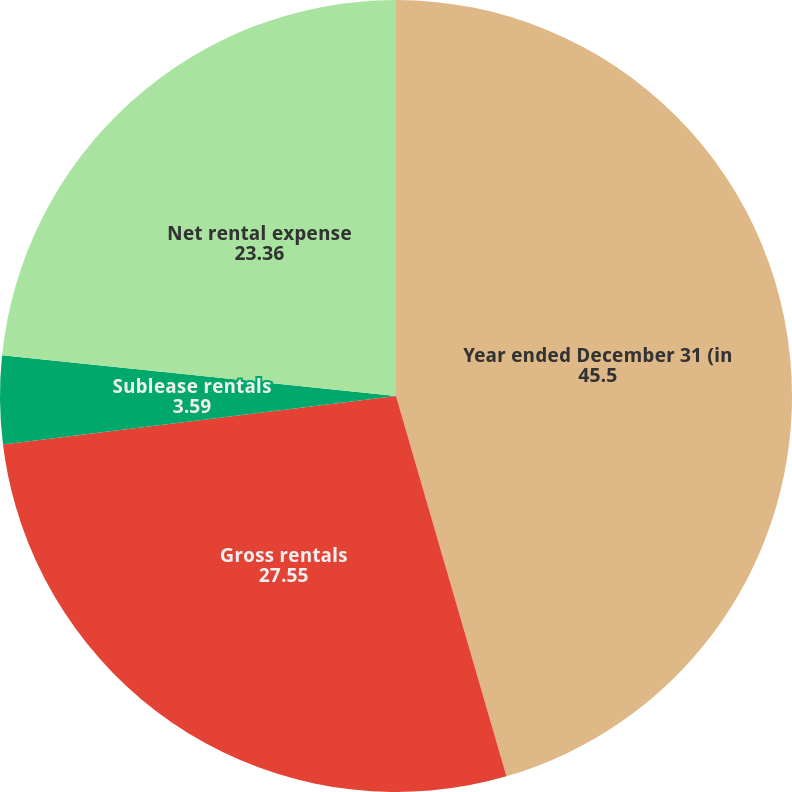Convert chart. <chart><loc_0><loc_0><loc_500><loc_500><pie_chart><fcel>Year ended December 31 (in<fcel>Gross rentals<fcel>Sublease rentals<fcel>Net rental expense<nl><fcel>45.5%<fcel>27.55%<fcel>3.59%<fcel>23.36%<nl></chart> 